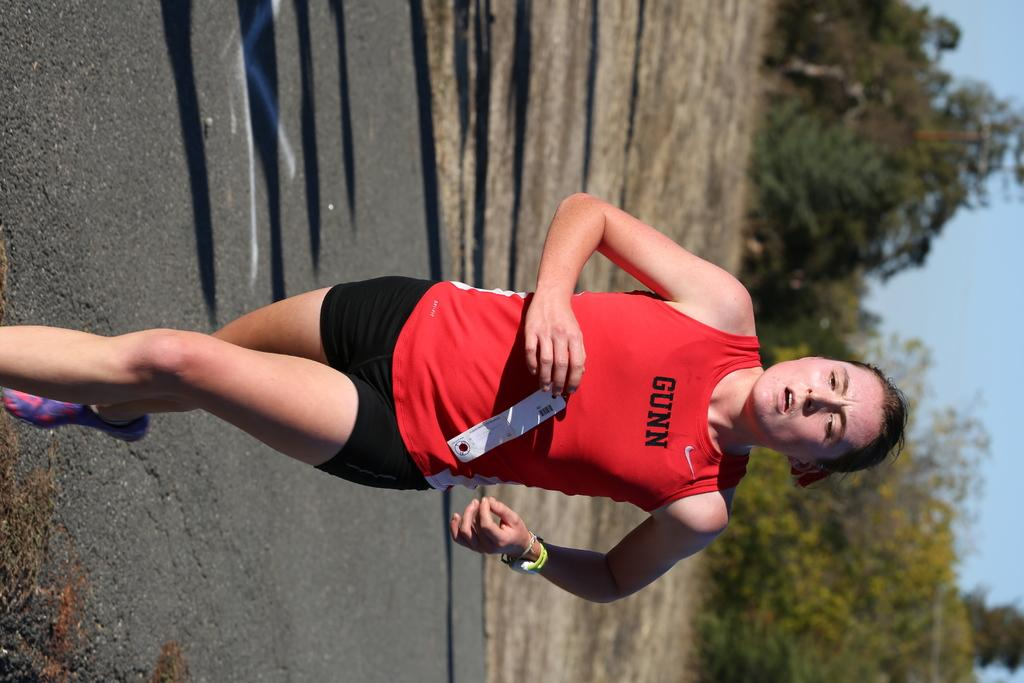What is happening in the image? There is a person in the image, and they are running. What is the person wearing? The person is wearing a red and black color dress. What can be seen in the background of the image? There are trees and the sky visible in the image. Where is the cushion placed in the image? There is no cushion present in the image. What type of toad can be seen hopping in the image? There is no toad present in the image. 